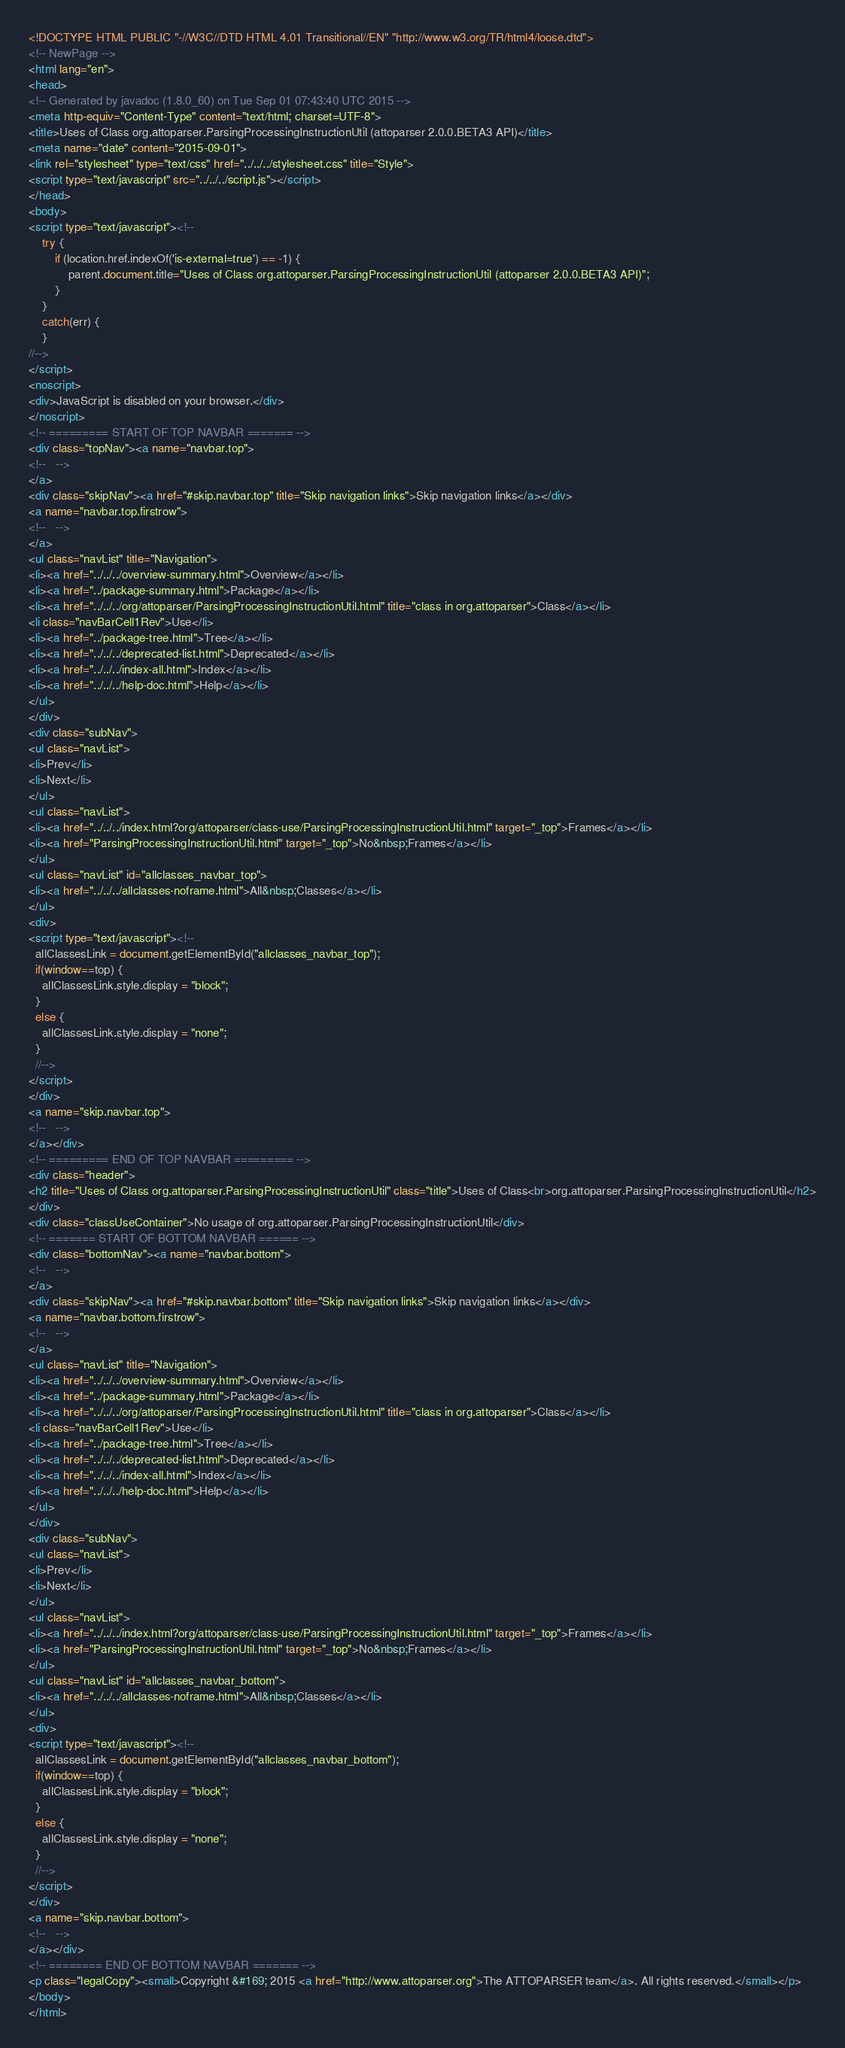Convert code to text. <code><loc_0><loc_0><loc_500><loc_500><_HTML_><!DOCTYPE HTML PUBLIC "-//W3C//DTD HTML 4.01 Transitional//EN" "http://www.w3.org/TR/html4/loose.dtd">
<!-- NewPage -->
<html lang="en">
<head>
<!-- Generated by javadoc (1.8.0_60) on Tue Sep 01 07:43:40 UTC 2015 -->
<meta http-equiv="Content-Type" content="text/html; charset=UTF-8">
<title>Uses of Class org.attoparser.ParsingProcessingInstructionUtil (attoparser 2.0.0.BETA3 API)</title>
<meta name="date" content="2015-09-01">
<link rel="stylesheet" type="text/css" href="../../../stylesheet.css" title="Style">
<script type="text/javascript" src="../../../script.js"></script>
</head>
<body>
<script type="text/javascript"><!--
    try {
        if (location.href.indexOf('is-external=true') == -1) {
            parent.document.title="Uses of Class org.attoparser.ParsingProcessingInstructionUtil (attoparser 2.0.0.BETA3 API)";
        }
    }
    catch(err) {
    }
//-->
</script>
<noscript>
<div>JavaScript is disabled on your browser.</div>
</noscript>
<!-- ========= START OF TOP NAVBAR ======= -->
<div class="topNav"><a name="navbar.top">
<!--   -->
</a>
<div class="skipNav"><a href="#skip.navbar.top" title="Skip navigation links">Skip navigation links</a></div>
<a name="navbar.top.firstrow">
<!--   -->
</a>
<ul class="navList" title="Navigation">
<li><a href="../../../overview-summary.html">Overview</a></li>
<li><a href="../package-summary.html">Package</a></li>
<li><a href="../../../org/attoparser/ParsingProcessingInstructionUtil.html" title="class in org.attoparser">Class</a></li>
<li class="navBarCell1Rev">Use</li>
<li><a href="../package-tree.html">Tree</a></li>
<li><a href="../../../deprecated-list.html">Deprecated</a></li>
<li><a href="../../../index-all.html">Index</a></li>
<li><a href="../../../help-doc.html">Help</a></li>
</ul>
</div>
<div class="subNav">
<ul class="navList">
<li>Prev</li>
<li>Next</li>
</ul>
<ul class="navList">
<li><a href="../../../index.html?org/attoparser/class-use/ParsingProcessingInstructionUtil.html" target="_top">Frames</a></li>
<li><a href="ParsingProcessingInstructionUtil.html" target="_top">No&nbsp;Frames</a></li>
</ul>
<ul class="navList" id="allclasses_navbar_top">
<li><a href="../../../allclasses-noframe.html">All&nbsp;Classes</a></li>
</ul>
<div>
<script type="text/javascript"><!--
  allClassesLink = document.getElementById("allclasses_navbar_top");
  if(window==top) {
    allClassesLink.style.display = "block";
  }
  else {
    allClassesLink.style.display = "none";
  }
  //-->
</script>
</div>
<a name="skip.navbar.top">
<!--   -->
</a></div>
<!-- ========= END OF TOP NAVBAR ========= -->
<div class="header">
<h2 title="Uses of Class org.attoparser.ParsingProcessingInstructionUtil" class="title">Uses of Class<br>org.attoparser.ParsingProcessingInstructionUtil</h2>
</div>
<div class="classUseContainer">No usage of org.attoparser.ParsingProcessingInstructionUtil</div>
<!-- ======= START OF BOTTOM NAVBAR ====== -->
<div class="bottomNav"><a name="navbar.bottom">
<!--   -->
</a>
<div class="skipNav"><a href="#skip.navbar.bottom" title="Skip navigation links">Skip navigation links</a></div>
<a name="navbar.bottom.firstrow">
<!--   -->
</a>
<ul class="navList" title="Navigation">
<li><a href="../../../overview-summary.html">Overview</a></li>
<li><a href="../package-summary.html">Package</a></li>
<li><a href="../../../org/attoparser/ParsingProcessingInstructionUtil.html" title="class in org.attoparser">Class</a></li>
<li class="navBarCell1Rev">Use</li>
<li><a href="../package-tree.html">Tree</a></li>
<li><a href="../../../deprecated-list.html">Deprecated</a></li>
<li><a href="../../../index-all.html">Index</a></li>
<li><a href="../../../help-doc.html">Help</a></li>
</ul>
</div>
<div class="subNav">
<ul class="navList">
<li>Prev</li>
<li>Next</li>
</ul>
<ul class="navList">
<li><a href="../../../index.html?org/attoparser/class-use/ParsingProcessingInstructionUtil.html" target="_top">Frames</a></li>
<li><a href="ParsingProcessingInstructionUtil.html" target="_top">No&nbsp;Frames</a></li>
</ul>
<ul class="navList" id="allclasses_navbar_bottom">
<li><a href="../../../allclasses-noframe.html">All&nbsp;Classes</a></li>
</ul>
<div>
<script type="text/javascript"><!--
  allClassesLink = document.getElementById("allclasses_navbar_bottom");
  if(window==top) {
    allClassesLink.style.display = "block";
  }
  else {
    allClassesLink.style.display = "none";
  }
  //-->
</script>
</div>
<a name="skip.navbar.bottom">
<!--   -->
</a></div>
<!-- ======== END OF BOTTOM NAVBAR ======= -->
<p class="legalCopy"><small>Copyright &#169; 2015 <a href="http://www.attoparser.org">The ATTOPARSER team</a>. All rights reserved.</small></p>
</body>
</html>
</code> 